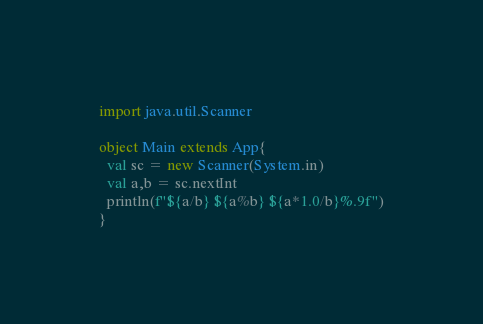<code> <loc_0><loc_0><loc_500><loc_500><_Scala_>import java.util.Scanner

object Main extends App{
  val sc = new Scanner(System.in)
  val a,b = sc.nextInt
  println(f"${a/b} ${a%b} ${a*1.0/b}%.9f")
}</code> 